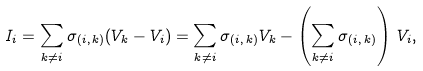<formula> <loc_0><loc_0><loc_500><loc_500>I _ { i } = \sum _ { k \neq i } \sigma _ { ( i , \, k ) } ( V _ { k } - V _ { i } ) = \sum _ { k \neq i } \sigma _ { ( i , \, k ) } V _ { k } - \left ( \sum _ { k \neq i } \sigma _ { ( i , \, k ) } \right ) \, V _ { i } ,</formula> 